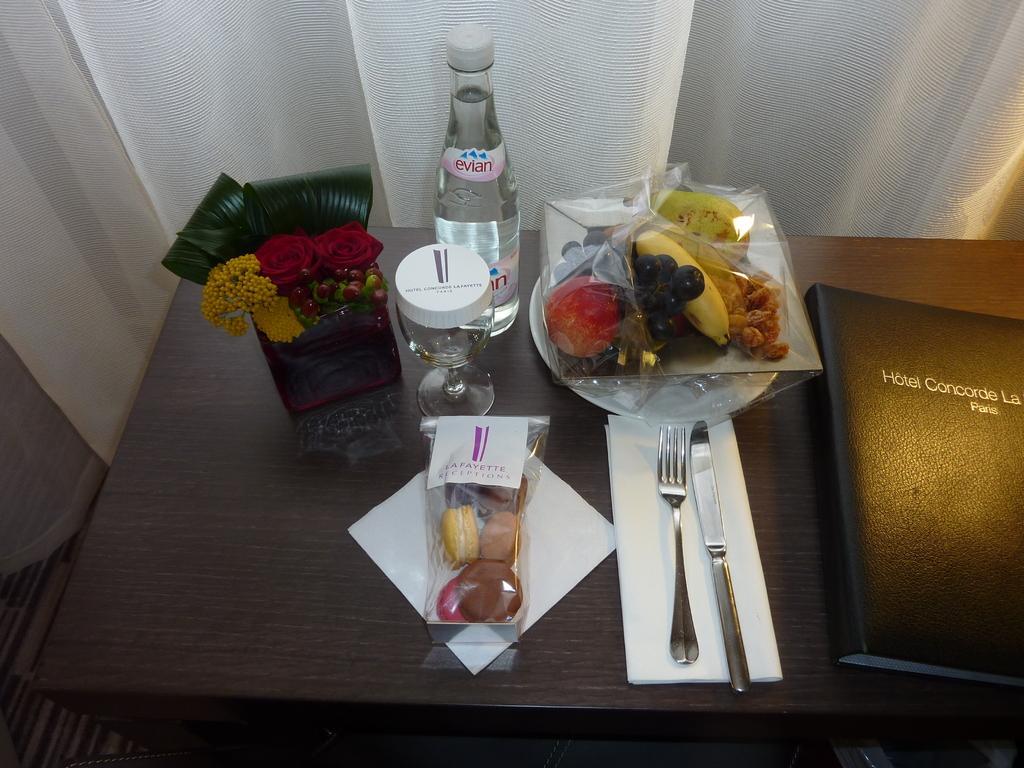Could you give a brief overview of what you see in this image? In the picture there is a table. And on the table there is a menu book, plate, fork, knife wine glass, bottle, holder with flowers in it, fruits and muffins. In the background does curtain. 